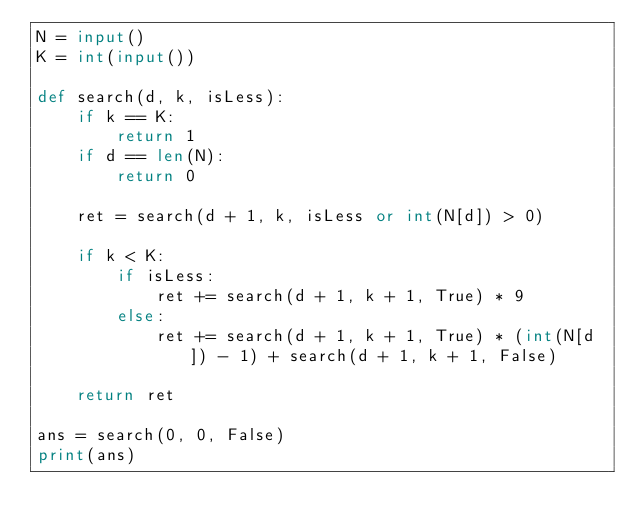<code> <loc_0><loc_0><loc_500><loc_500><_Python_>N = input()
K = int(input())

def search(d, k, isLess):
    if k == K:
        return 1
    if d == len(N):
        return 0

    ret = search(d + 1, k, isLess or int(N[d]) > 0)

    if k < K:
        if isLess:
            ret += search(d + 1, k + 1, True) * 9
        else:
            ret += search(d + 1, k + 1, True) * (int(N[d]) - 1) + search(d + 1, k + 1, False)

    return ret

ans = search(0, 0, False)
print(ans)</code> 